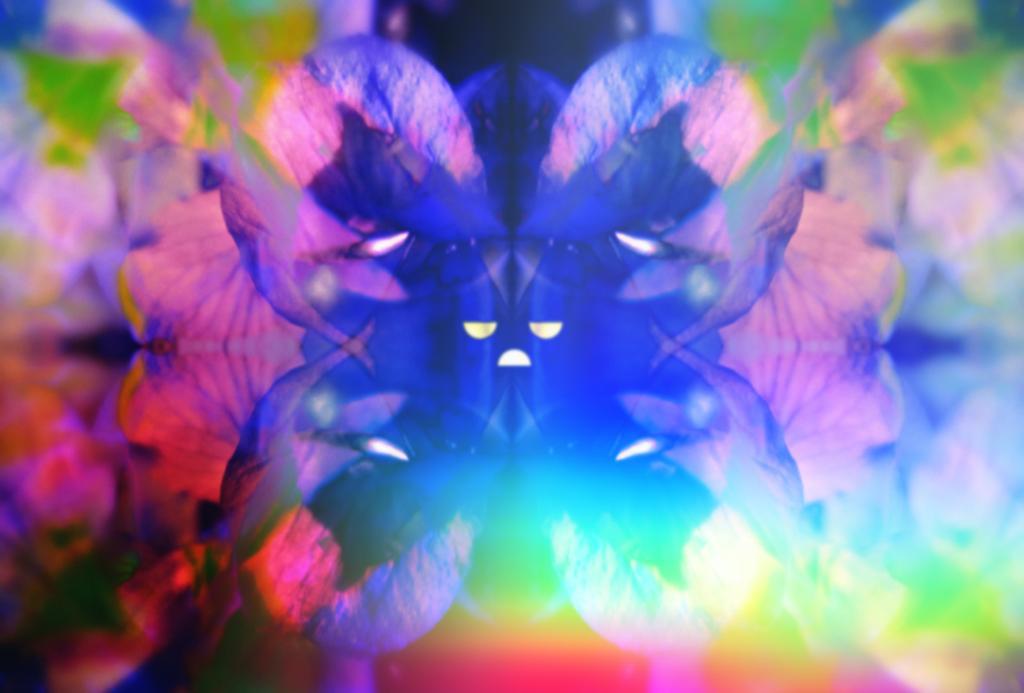How would you summarize this image in a sentence or two? In this image we can see flowers. 